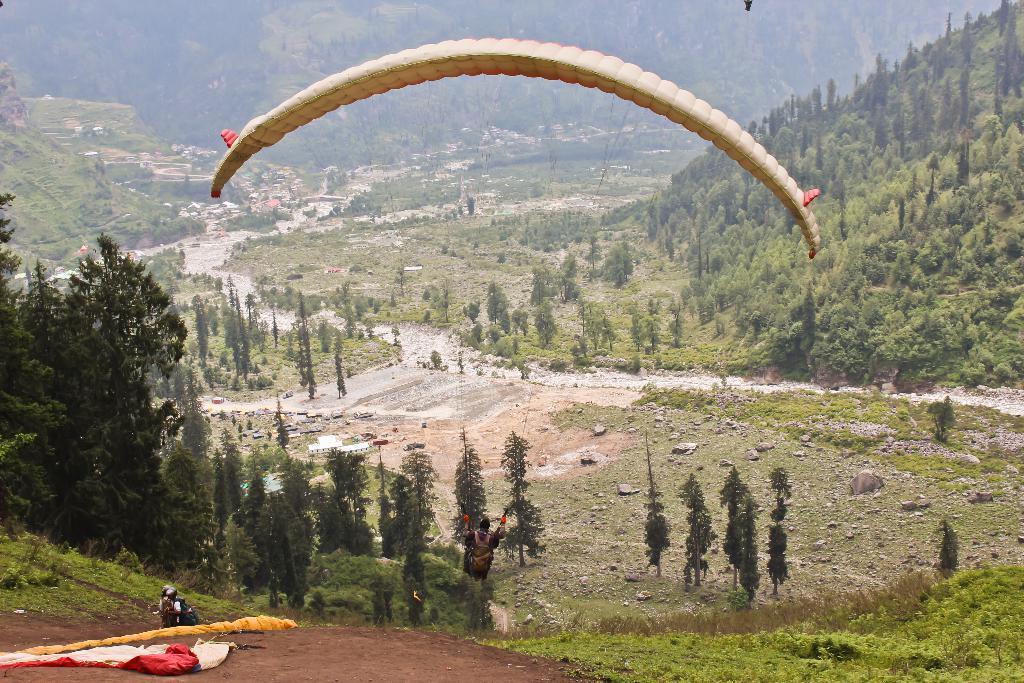Describe this image in one or two sentences. In this picture I can see few persons, there is a person parachuting with a parachute, there are buildings, there are trees and hills. 